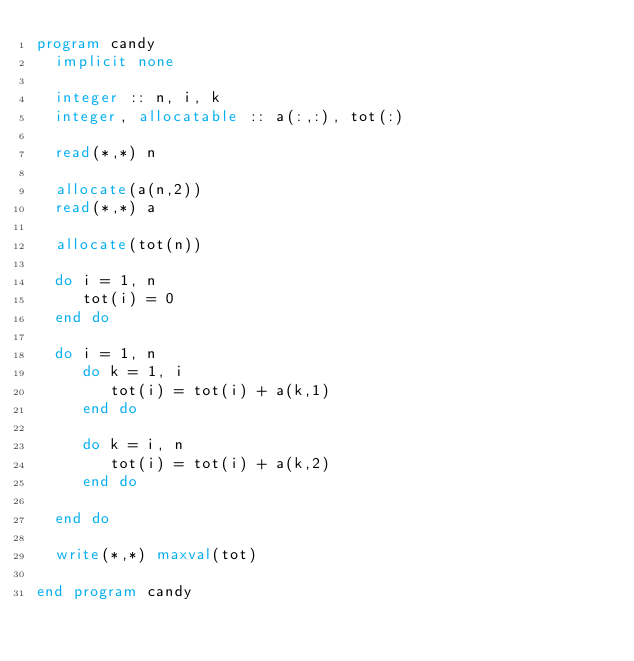<code> <loc_0><loc_0><loc_500><loc_500><_FORTRAN_>program candy
  implicit none

  integer :: n, i, k
  integer, allocatable :: a(:,:), tot(:)

  read(*,*) n

  allocate(a(n,2))
  read(*,*) a

  allocate(tot(n))

  do i = 1, n
     tot(i) = 0
  end do

  do i = 1, n
     do k = 1, i
        tot(i) = tot(i) + a(k,1)
     end do

     do k = i, n
        tot(i) = tot(i) + a(k,2)
     end do

  end do

  write(*,*) maxval(tot)

end program candy

     

  

  
</code> 